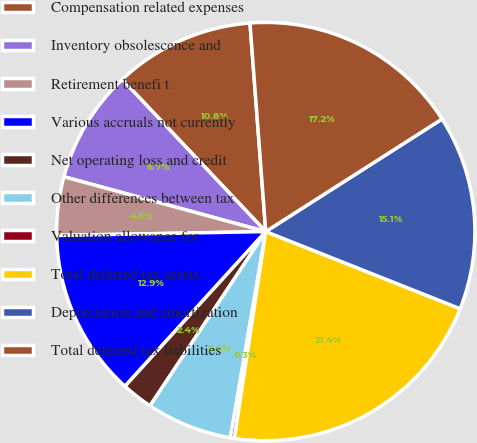Convert chart. <chart><loc_0><loc_0><loc_500><loc_500><pie_chart><fcel>Compensation related expenses<fcel>Inventory obsolescence and<fcel>Retirement benefi t<fcel>Various accruals not currently<fcel>Net operating loss and credit<fcel>Other differences between tax<fcel>Valuation allowance for<fcel>Total deferred tax assets<fcel>Depreciation and amortization<fcel>Total deferred tax liabilities<nl><fcel>10.84%<fcel>8.74%<fcel>4.52%<fcel>12.95%<fcel>2.42%<fcel>6.63%<fcel>0.31%<fcel>21.38%<fcel>15.06%<fcel>17.16%<nl></chart> 